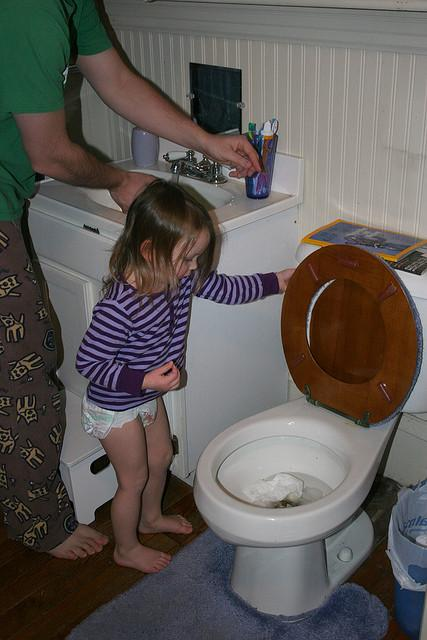What is the toddler about to do?

Choices:
A) flush toilet
B) poo
C) throw up
D) pee flush toilet 